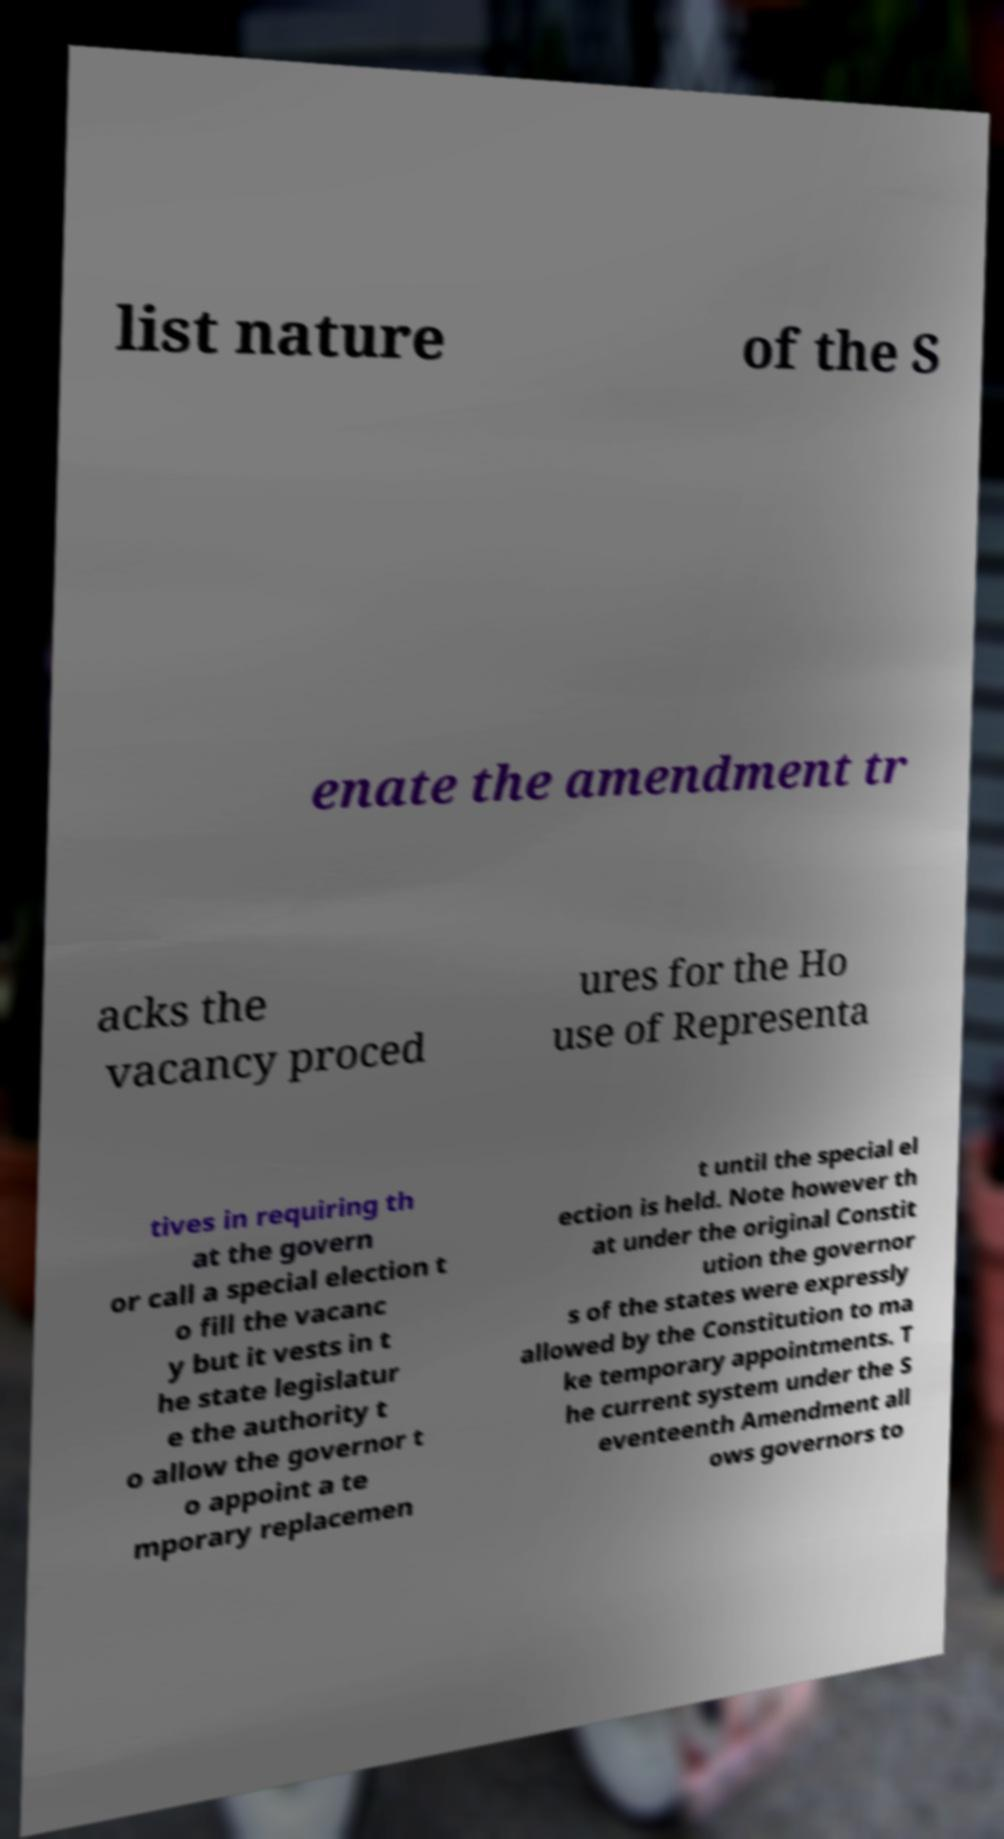For documentation purposes, I need the text within this image transcribed. Could you provide that? list nature of the S enate the amendment tr acks the vacancy proced ures for the Ho use of Representa tives in requiring th at the govern or call a special election t o fill the vacanc y but it vests in t he state legislatur e the authority t o allow the governor t o appoint a te mporary replacemen t until the special el ection is held. Note however th at under the original Constit ution the governor s of the states were expressly allowed by the Constitution to ma ke temporary appointments. T he current system under the S eventeenth Amendment all ows governors to 